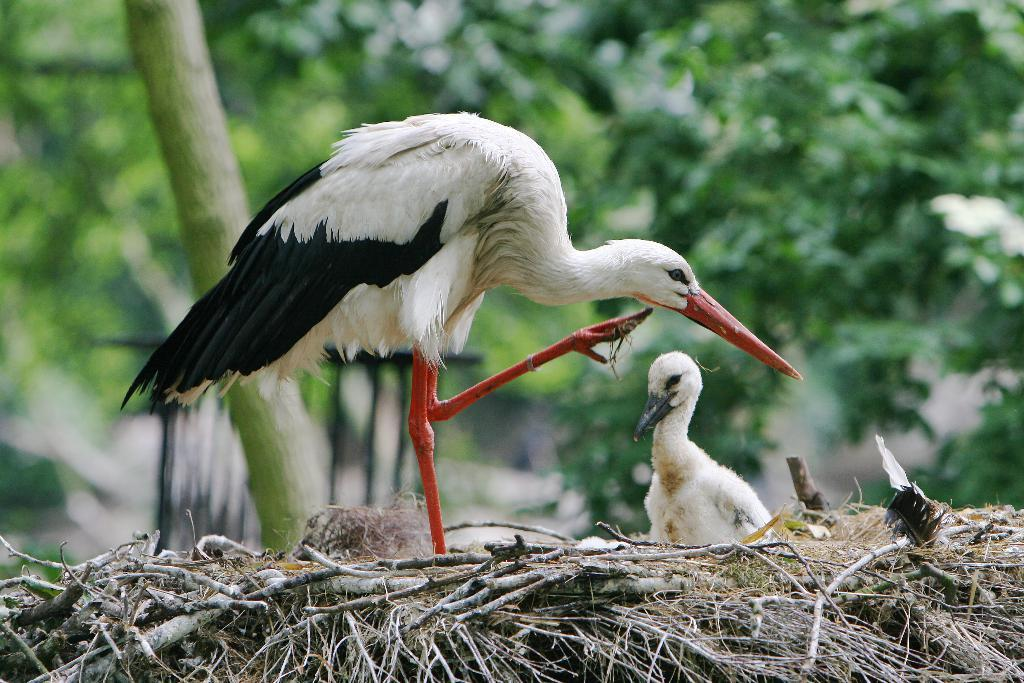How many birds are present in the image? There are two birds in the image. What colors are the birds? The birds are in white and black color. What can be seen in the background of the image? There are trees in the background of the image. What is the color of the trees? The trees are green in color. What type of flowers are growing around the goose in the image? There is no goose present in the image, and therefore no flowers can be observed around it. 